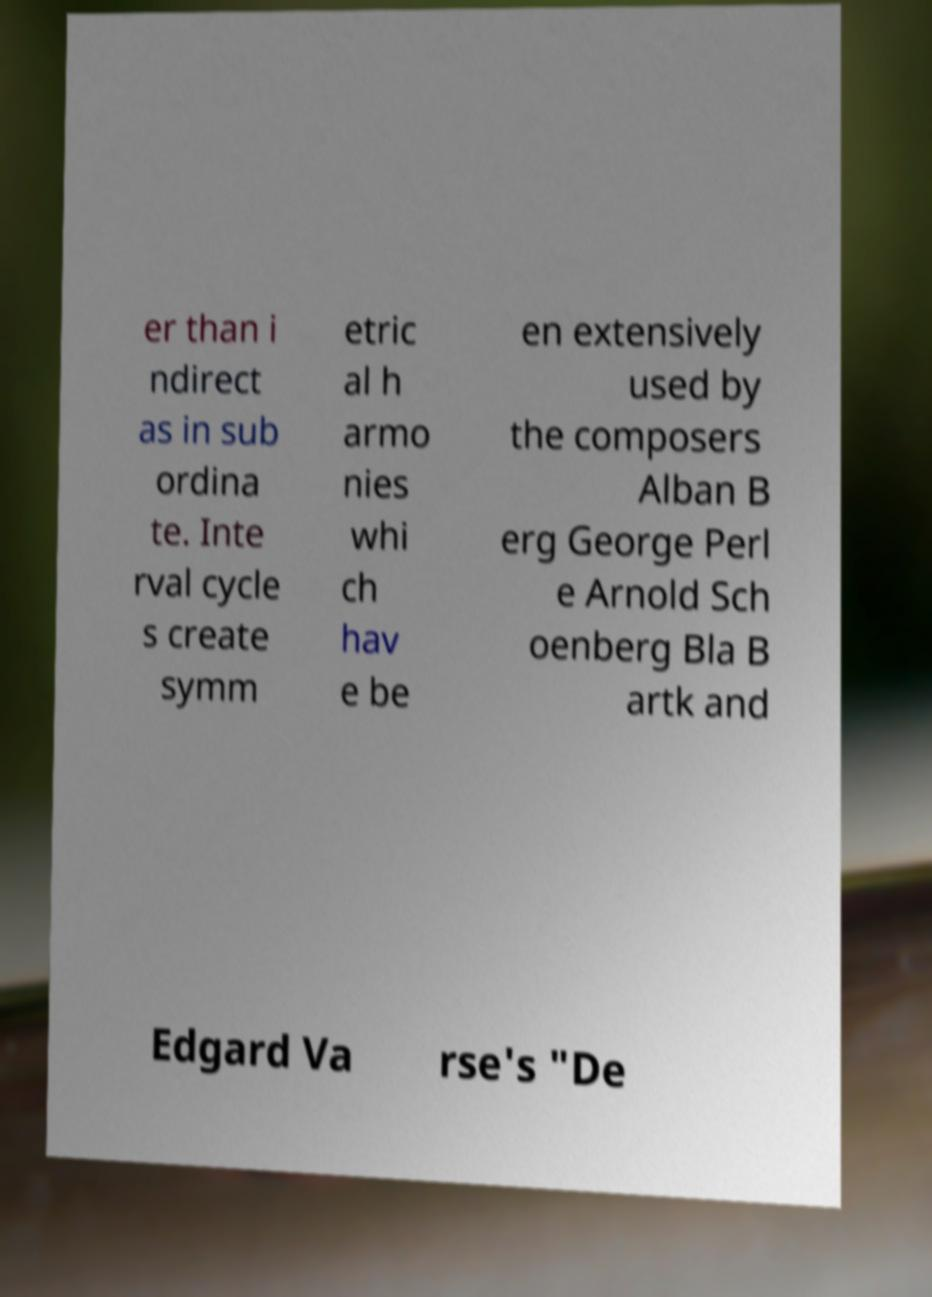Can you read and provide the text displayed in the image?This photo seems to have some interesting text. Can you extract and type it out for me? er than i ndirect as in sub ordina te. Inte rval cycle s create symm etric al h armo nies whi ch hav e be en extensively used by the composers Alban B erg George Perl e Arnold Sch oenberg Bla B artk and Edgard Va rse's "De 